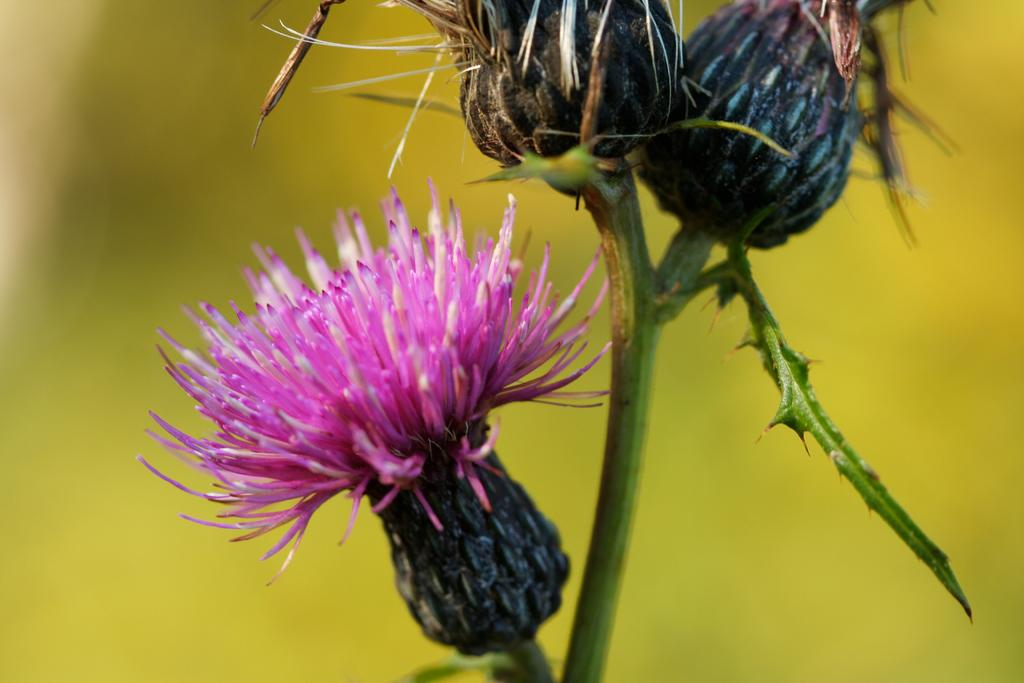What type of flower is in the image? There is a pink flower on a stem in the image. What is the flower resting on? The flower is on a leaf. Are there any additional features of the leaf? Yes, the leaf has thorns. How would you describe the background of the image? The background of the image is blurred. What type of shoe can be seen in the image? There is no shoe present in the image; it features a pink flower on a leaf with thorns. What type of beef is being served in the image? There is no beef present in the image; it features a pink flower on a leaf with thorns. 